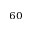<formula> <loc_0><loc_0><loc_500><loc_500>^ { 6 0 }</formula> 